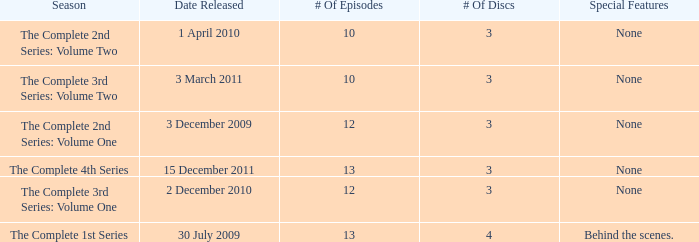On how many dates was the complete 4th series released? 1.0. 